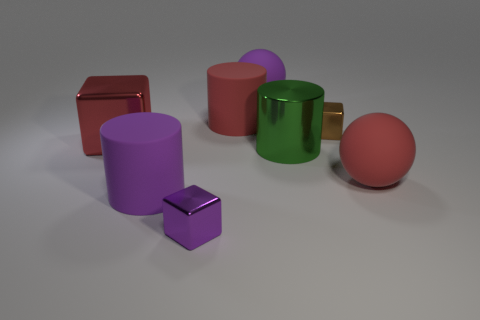Can you describe the shapes and colors present in this image? Certainly! The image depicts six 3D-rendered objects comprised of various geometric shapes in distinct colors. From left to right, we have a shiny red rectangular block, a matte purple cylinder, a reflective green mug with a golden handle, a glossy red sphere, a smaller matte purple cube, and a reflective pink sphere. 